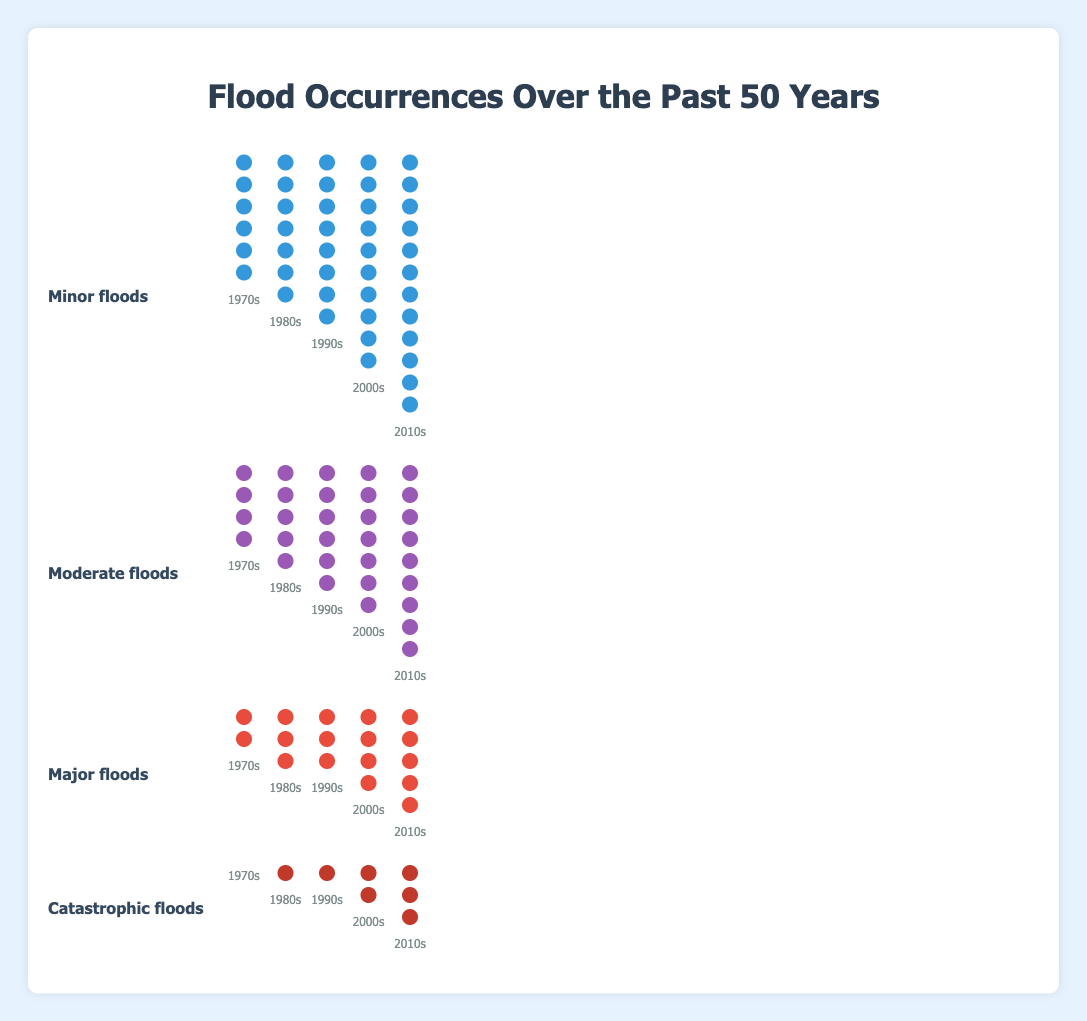What is the title of the figure? The title is located at the top of the figure, indicating the overall topic. It reads "Flood Occurrences Over the Past 50 Years".
Answer: Flood Occurrences Over the Past 50 Years Which category had no occurrences in the 1970s? Look for the icons representing each decade for each category. The "Catastrophic floods" category had no icons in the 1970s column.
Answer: Catastrophic floods How many minor flood occurrences were in the 2010s? Count the icons labeled as "Minor floods" under the 2010s column. There are 12 circle icons.
Answer: 12 What is the increase in major flood occurrences from the 1970s to the 2010s? Count the "Major floods" icons in both the 1970s and 2010s columns and find the difference. The 1970s have 2 icons, and the 2010s have 5 icons, so the increase is 5 - 2.
Answer: 3 Which decade experienced the most moderate floods? Compare the number of "Moderate floods" icons across all decades. The 2010s have the most with 9 icons.
Answer: 2010s How does the frequency of major floods in the 2000s compare with the 1980s? Count the "Major floods" icons for each decade. The 2000s have 4 icons, and the 1980s have 3 icons. Since 4 > 3, the 2000s have more.
Answer: 2000s have more Calculate the total number of flood occurrences in the 1990s for all categories combined. Sum the number of flood occurrences for all categories in the 1990s: Minor (8), Moderate (6), Major (3), Catastrophic (1). The total is 8 + 6 + 3 + 1.
Answer: 18 Which category showed the most consistent increase in occurrences across decades? Examine the trend of occurrences for each category across all decades. "Minor floods" increases steadily (6, 7, 8, 10, 12).
Answer: Minor floods What was the average number of catastrophic flood occurrences per decade? Add the occurrences for each decade: 0, 1, 1, 2, 3, then divide by the number of decades. (0 + 1 + 1 + 2 + 3) / 5 = 1.4.
Answer: 1.4 How many more moderate floods occurred in the 2010s compared to the 1970s? Subtract the number of moderate flood icons in the 1970s (4) from those in the 2010s (9). 9 - 4 = 5.
Answer: 5 